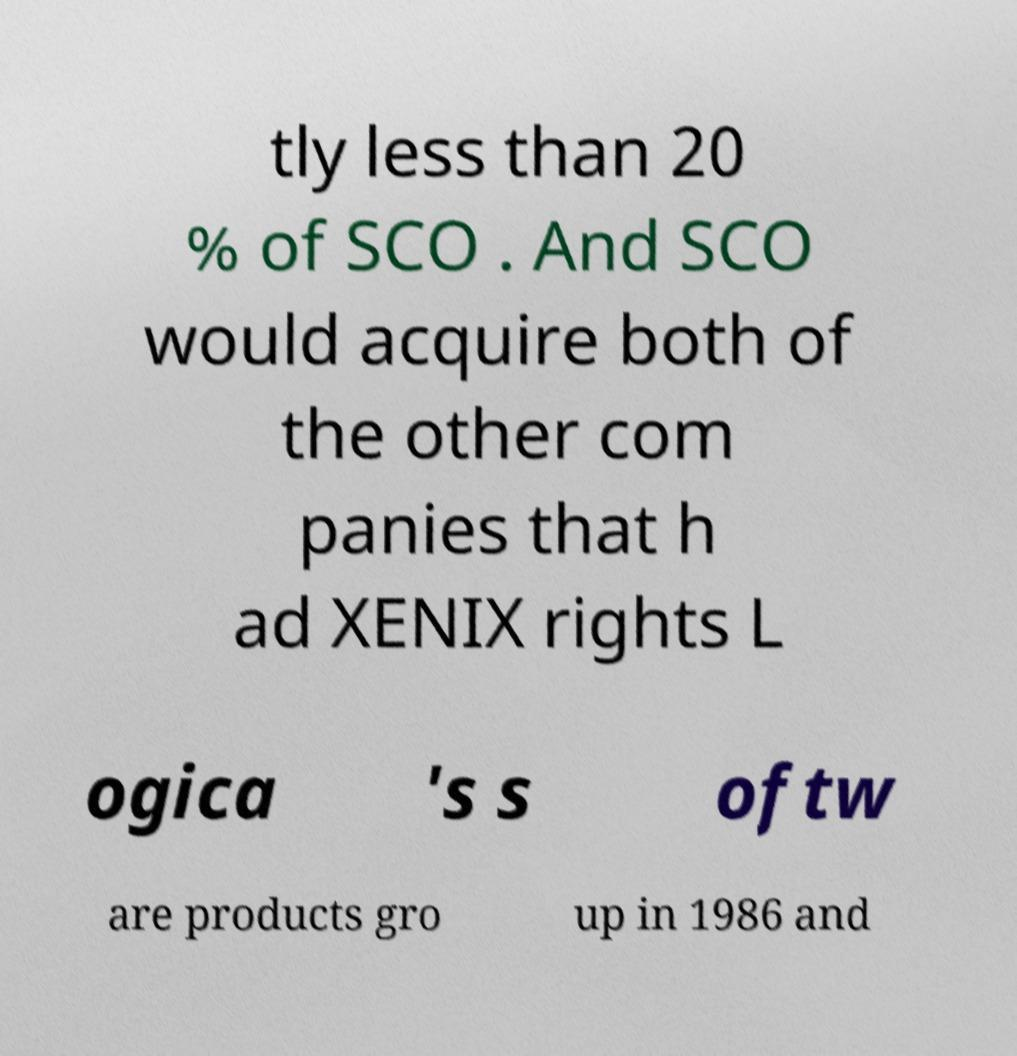Could you extract and type out the text from this image? tly less than 20 % of SCO . And SCO would acquire both of the other com panies that h ad XENIX rights L ogica 's s oftw are products gro up in 1986 and 